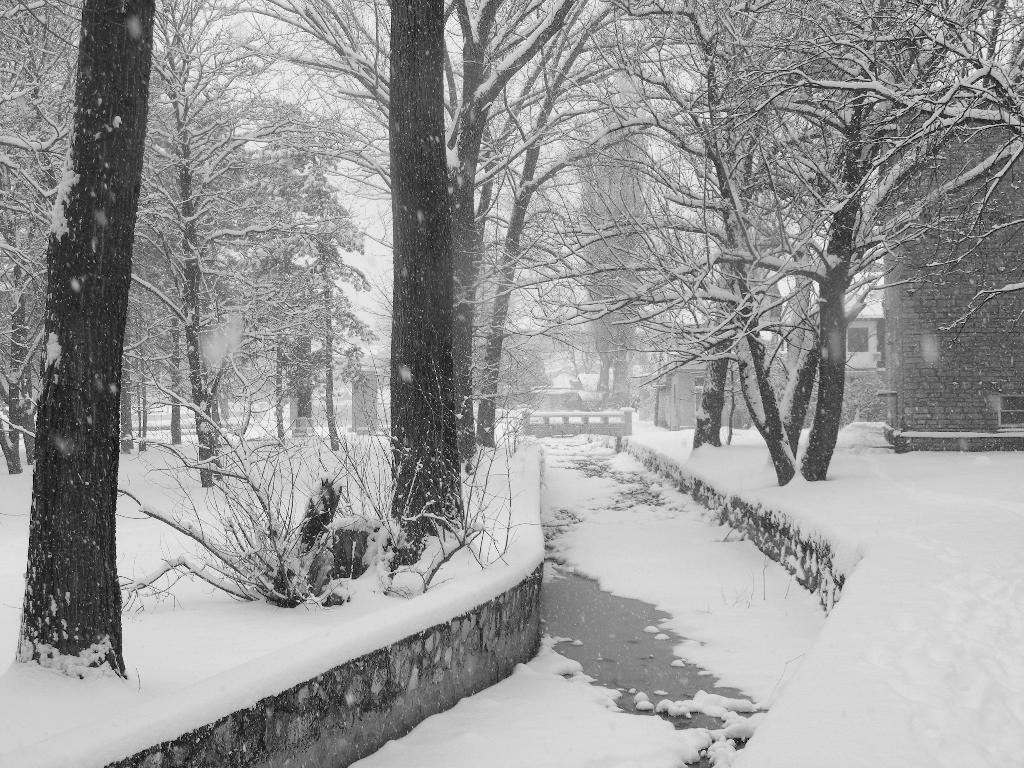What type of structures can be seen in the image? There are buildings in the image. What other natural elements are present in the image? There are trees in the image. What is the weather condition in the image? Snow is visible around the buildings and trees, indicating a snowy environment. How many rings can be seen on the doll's finger in the image? There are no dolls or rings present in the image. 